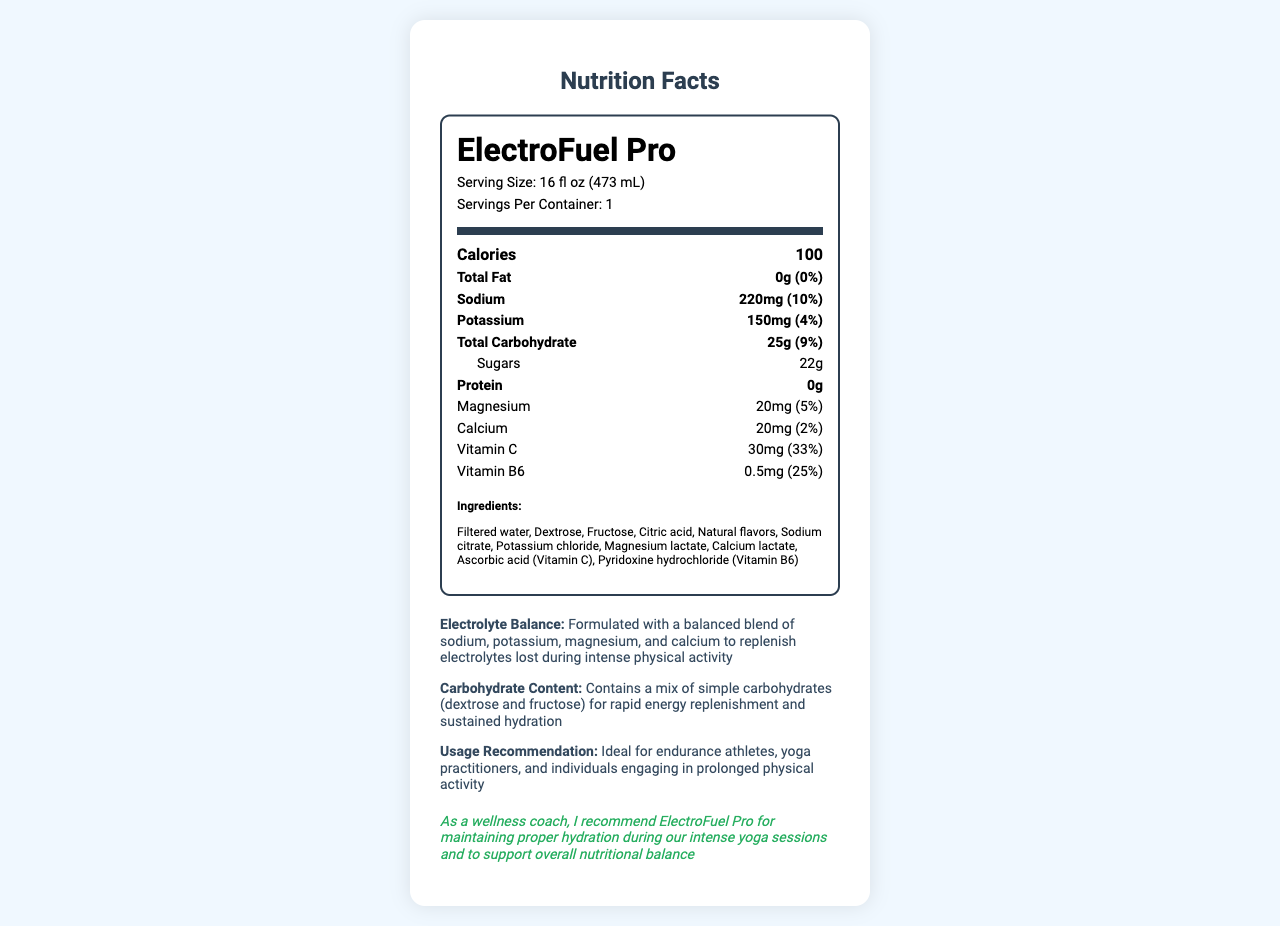what is the serving size? The serving size is listed as "Serving Size: 16 fl oz (473 mL)" in the document.
Answer: 16 fl oz (473 mL) how many calories are in one serving of ElectroFuel Pro? The document states "Calories: 100" in the nutrition label.
Answer: 100 what is the sodium content per serving? The sodium content per serving is noted as "Sodium: 220mg (10%)" in the nutrition label.
Answer: 220mg how many grams of sugars does this sports drink contain? The amount of sugars is mentioned as "Sugars: 22g" under the Total Carbohydrate section.
Answer: 22g what are the primary electrolytes mentioned in this product? The key electrolytes are highlighted in the "additional_info" section as sodium, potassium, magnesium, and calcium.
Answer: Sodium, Potassium, Magnesium, Calcium what is the daily value percentage of Vitamin C provided by one serving? The daily value percentage for Vitamin C is listed as "Vitamin C: 30mg (33%)" in the document.
Answer: 33% which ingredients in ElectroFuel Pro contribute to its carbohydrate content? A. Dextrose and Fructose B. Sodium and Potassium C. Magnesium and Calcium D. Water and Citric Acid The carbohydrate content comes from "Dextrose" and "Fructose" as mentioned in the ingredients list and the additional carbohydrate content information.
Answer: A what is the primary function of ElectroFuel Pro as suggested by the wellness coach note? A. Weight loss B. Muscle gain C. Hydration and nutritional balance D. Protein intake The wellness coach note emphasizes the product's role in maintaining proper hydration and supporting overall nutritional balance.
Answer: C is ElectoFuel Pro recommended for prolonged physical activities? The usage recommendation states it is ideal for endurance athletes, yoga practitioners, and those engaging in prolonged physical activity.
Answer: Yes summarize the overall information conveyed by the document. The document provides a detailed nutritional analysis and highlights the benefits and usage recommendations of ElectroFuel Pro, emphasizing its role in hydration and energy replenishment during prolonged physical activities.
Answer: ElectroFuel Pro is a sports drink formulated to maintain electrolyte balance and provide rapid energy replenishment through a mix of sodium, potassium, magnesium, and calcium. It is particularly suitable for endurance athletes and yoga practitioners. The nutrition label indicates it contains 100 calories per serving, with significant amounts of sodium and carbohydrates, including 22g of sugars. The drink is enriched with vitamins C and B6, and the ingredients include dextrose, fructose, and various electrolytes. The wellness coach recommends it for hydration during intense yoga sessions and overall nutritional balance. is there information about the flavor of ElectroFuel Pro? The document does not provide details about the flavor of ElectroFuel Pro. It only mentions "Natural flavors" in the ingredients list without specifying the taste.
Answer: No 